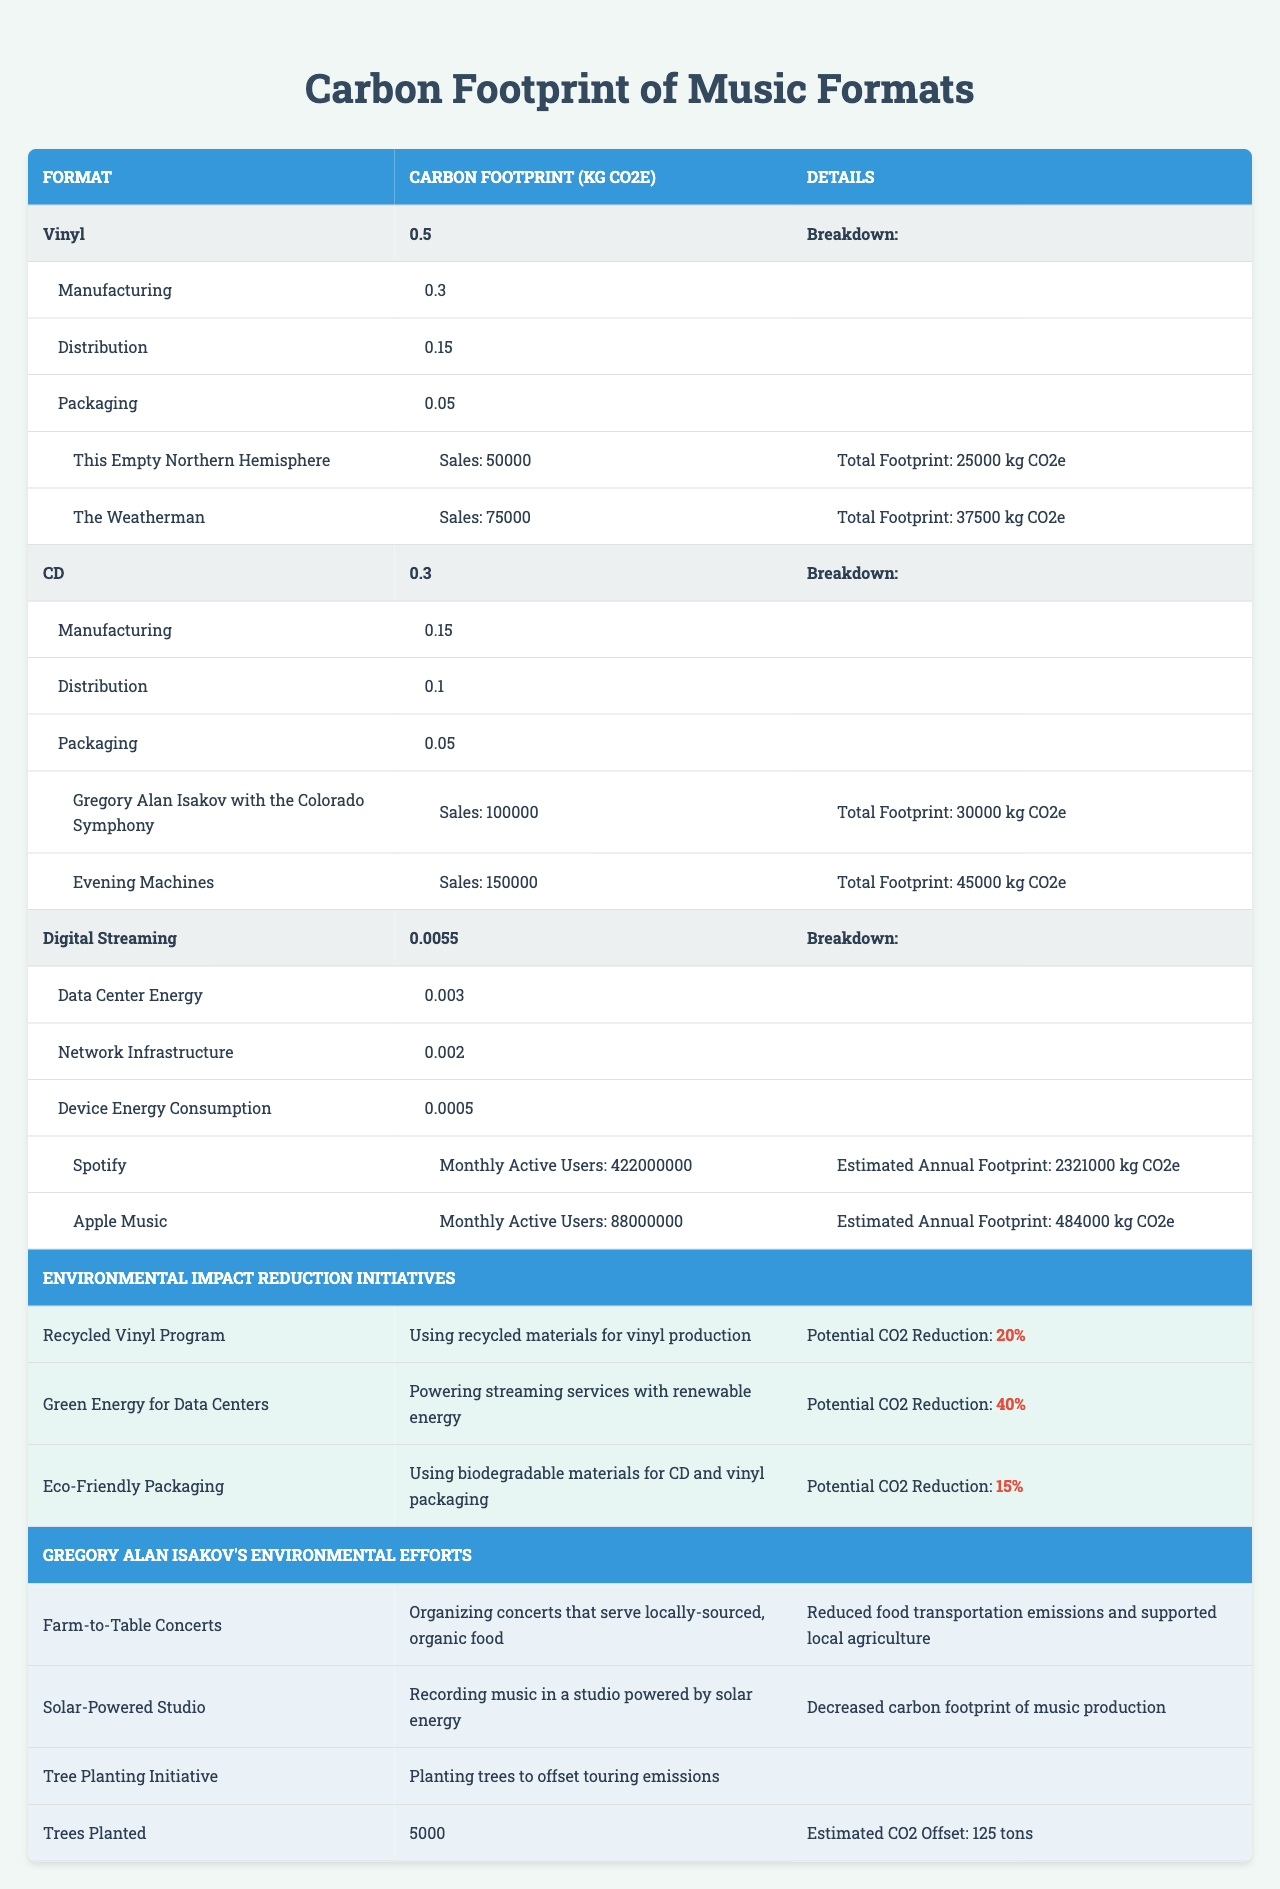What is the carbon footprint of vinyl music consumption? The table shows that the carbon footprint for vinyl music consumption is 0.5 kg CO2e.
Answer: 0.5 kg CO2e How much CO2e does digital streaming produce compared to CDs? The carbon footprint of digital streaming is 0.0055 kg CO2e, while for CDs it is 0.3 kg CO2e. To compare, digital streaming produces significantly less CO2e than CDs.
Answer: Digital streaming produces less CO2e than CDs What is the total carbon footprint for "The Weatherman" album? The table indicates "The Weatherman" album has a total footprint of 37,500 kg CO2e.
Answer: 37,500 kg CO2e Which music format has the highest carbon footprint? The carbon footprints listed are 0.5 kg CO2e for vinyl, 0.3 kg CO2e for CDs, and 0.0055 kg CO2e for digital streaming. Vinyl has the highest carbon footprint.
Answer: Vinyl What is the total carbon footprint of the sales for the albums listed under CDs? The total for "Gregory Alan Isakov with the Colorado Symphony" is 30,000 kg CO2e and for "Evening Machines" is 45,000 kg CO2e. Adding these gives a total of 75,000 kg CO2e.
Answer: 75,000 kg CO2e How much CO2 could be potentially reduced by implementing the Green Energy for Data Centers initiative? The potential CO2 reduction from the Green Energy for Data Centers initiative is 40%. This information is stated directly in the table.
Answer: 40% What is the estimated annual carbon footprint for Spotify? According to the table, Spotify has an estimated annual carbon footprint of 2,321,000 kg CO2e.
Answer: 2,321,000 kg CO2e If all Isakov albums on vinyl are sold, what would be their total carbon footprint? The total footprint for "This Empty Northern Hemisphere" is 25,000 kg CO2e and for "The Weatherman" is 37,500 kg CO2e. Summing these gives a total of 62,500 kg CO2e.
Answer: 62,500 kg CO2e How many trees were planted as part of Isakov's Tree Planting Initiative? The table indicates that 5,000 trees were planted as part of this initiative.
Answer: 5,000 trees What is the combined potential CO2 reduction from the Eco-Friendly Packaging initiative and the Recycled Vinyl Program? The Eco-Friendly Packaging initiative has a potential CO2 reduction of 15%, and the Recycled Vinyl Program has a potential reduction of 20%. The total combined potential is therefore 35%.
Answer: 35% 